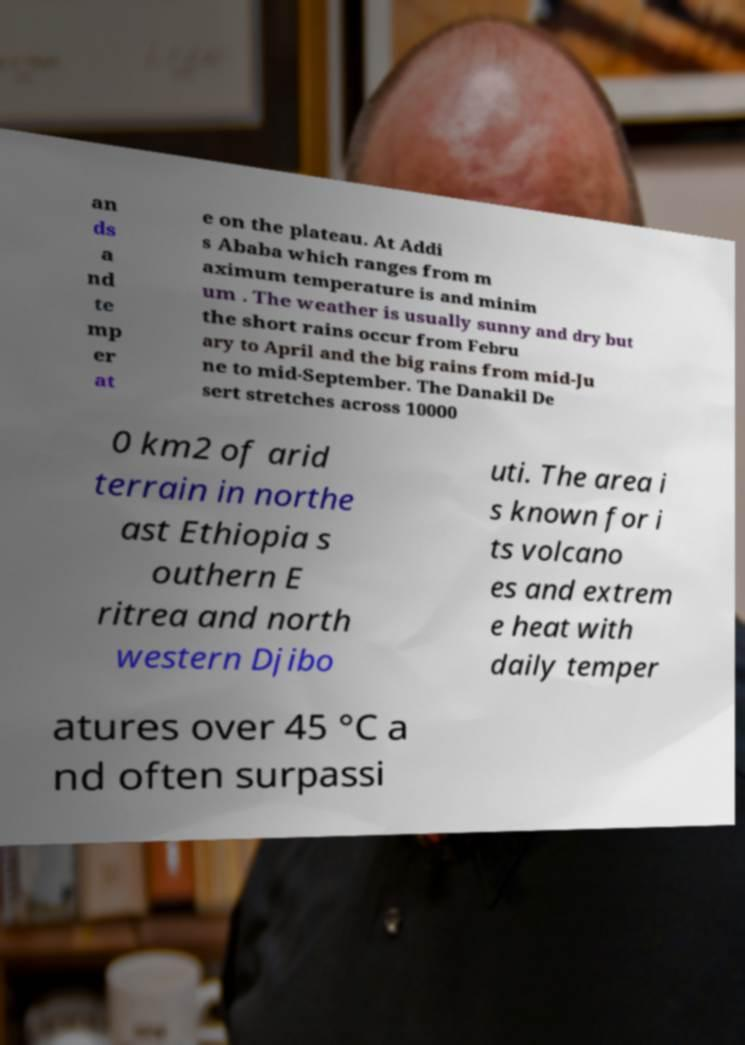What messages or text are displayed in this image? I need them in a readable, typed format. an ds a nd te mp er at e on the plateau. At Addi s Ababa which ranges from m aximum temperature is and minim um . The weather is usually sunny and dry but the short rains occur from Febru ary to April and the big rains from mid-Ju ne to mid-September. The Danakil De sert stretches across 10000 0 km2 of arid terrain in northe ast Ethiopia s outhern E ritrea and north western Djibo uti. The area i s known for i ts volcano es and extrem e heat with daily temper atures over 45 °C a nd often surpassi 